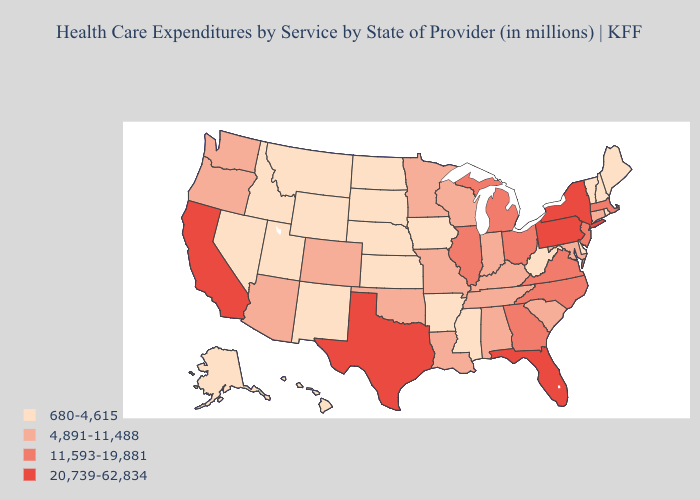Among the states that border Nevada , does Arizona have the lowest value?
Answer briefly. No. Does Delaware have the same value as Louisiana?
Concise answer only. No. Does Maine have a higher value than Hawaii?
Keep it brief. No. Name the states that have a value in the range 20,739-62,834?
Concise answer only. California, Florida, New York, Pennsylvania, Texas. Does the first symbol in the legend represent the smallest category?
Be succinct. Yes. What is the value of New York?
Keep it brief. 20,739-62,834. What is the lowest value in the MidWest?
Answer briefly. 680-4,615. Does Indiana have the lowest value in the MidWest?
Short answer required. No. What is the value of Wyoming?
Concise answer only. 680-4,615. What is the highest value in the Northeast ?
Answer briefly. 20,739-62,834. What is the value of Oklahoma?
Concise answer only. 4,891-11,488. What is the lowest value in the MidWest?
Give a very brief answer. 680-4,615. Does the map have missing data?
Quick response, please. No. Name the states that have a value in the range 4,891-11,488?
Give a very brief answer. Alabama, Arizona, Colorado, Connecticut, Indiana, Kentucky, Louisiana, Maryland, Minnesota, Missouri, Oklahoma, Oregon, South Carolina, Tennessee, Washington, Wisconsin. What is the lowest value in the USA?
Keep it brief. 680-4,615. 